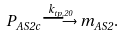Convert formula to latex. <formula><loc_0><loc_0><loc_500><loc_500>P _ { A S 2 c } \overset { k _ { t p , 2 0 } } { \longrightarrow } m _ { A S 2 } .</formula> 